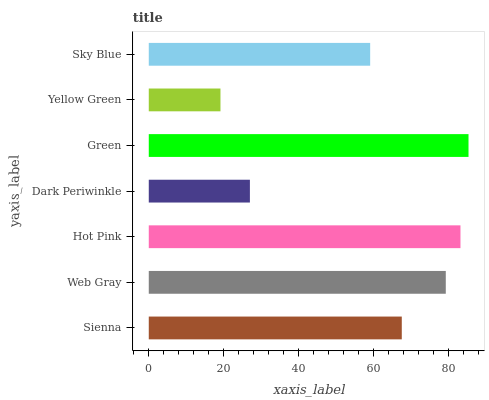Is Yellow Green the minimum?
Answer yes or no. Yes. Is Green the maximum?
Answer yes or no. Yes. Is Web Gray the minimum?
Answer yes or no. No. Is Web Gray the maximum?
Answer yes or no. No. Is Web Gray greater than Sienna?
Answer yes or no. Yes. Is Sienna less than Web Gray?
Answer yes or no. Yes. Is Sienna greater than Web Gray?
Answer yes or no. No. Is Web Gray less than Sienna?
Answer yes or no. No. Is Sienna the high median?
Answer yes or no. Yes. Is Sienna the low median?
Answer yes or no. Yes. Is Yellow Green the high median?
Answer yes or no. No. Is Sky Blue the low median?
Answer yes or no. No. 